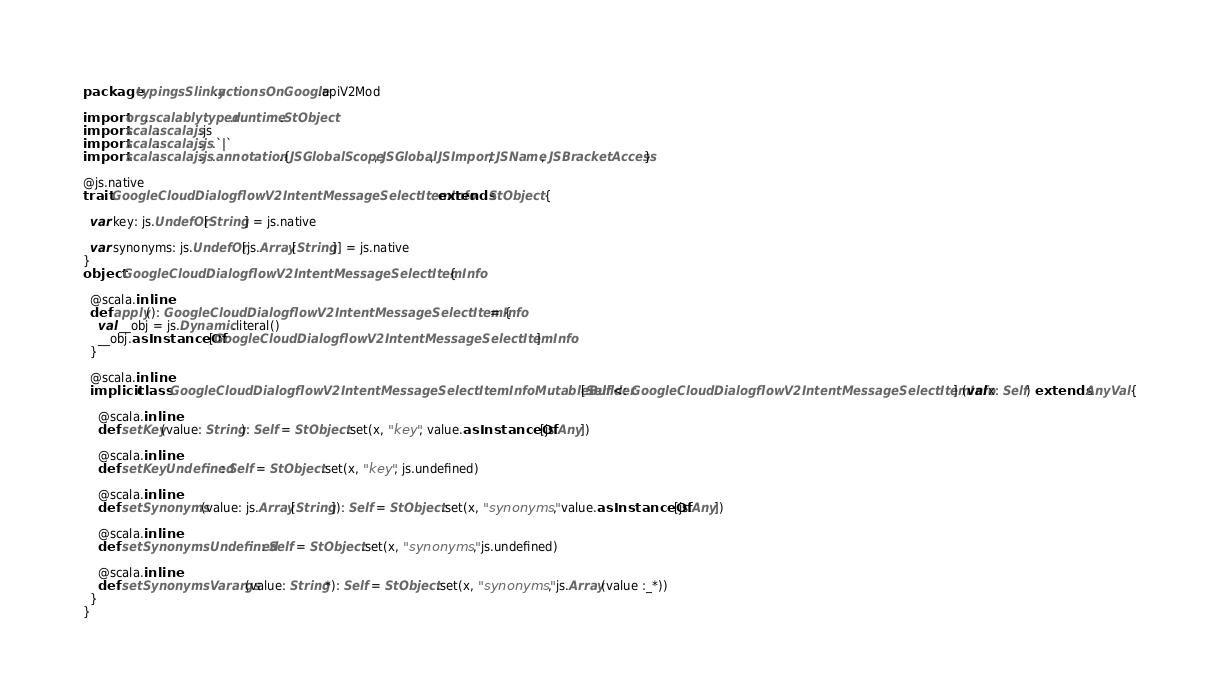Convert code to text. <code><loc_0><loc_0><loc_500><loc_500><_Scala_>package typingsSlinky.actionsOnGoogle.apiV2Mod

import org.scalablytyped.runtime.StObject
import scala.scalajs.js
import scala.scalajs.js.`|`
import scala.scalajs.js.annotation.{JSGlobalScope, JSGlobal, JSImport, JSName, JSBracketAccess}

@js.native
trait GoogleCloudDialogflowV2IntentMessageSelectItemInfo extends StObject {
  
  var key: js.UndefOr[String] = js.native
  
  var synonyms: js.UndefOr[js.Array[String]] = js.native
}
object GoogleCloudDialogflowV2IntentMessageSelectItemInfo {
  
  @scala.inline
  def apply(): GoogleCloudDialogflowV2IntentMessageSelectItemInfo = {
    val __obj = js.Dynamic.literal()
    __obj.asInstanceOf[GoogleCloudDialogflowV2IntentMessageSelectItemInfo]
  }
  
  @scala.inline
  implicit class GoogleCloudDialogflowV2IntentMessageSelectItemInfoMutableBuilder[Self <: GoogleCloudDialogflowV2IntentMessageSelectItemInfo] (val x: Self) extends AnyVal {
    
    @scala.inline
    def setKey(value: String): Self = StObject.set(x, "key", value.asInstanceOf[js.Any])
    
    @scala.inline
    def setKeyUndefined: Self = StObject.set(x, "key", js.undefined)
    
    @scala.inline
    def setSynonyms(value: js.Array[String]): Self = StObject.set(x, "synonyms", value.asInstanceOf[js.Any])
    
    @scala.inline
    def setSynonymsUndefined: Self = StObject.set(x, "synonyms", js.undefined)
    
    @scala.inline
    def setSynonymsVarargs(value: String*): Self = StObject.set(x, "synonyms", js.Array(value :_*))
  }
}
</code> 